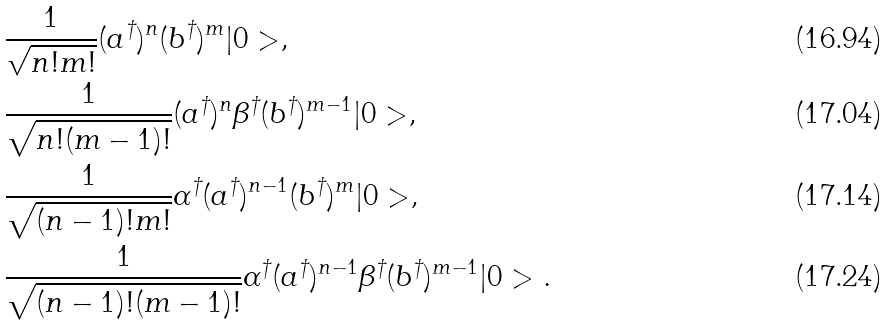Convert formula to latex. <formula><loc_0><loc_0><loc_500><loc_500>& \frac { 1 } { \sqrt { n ! m ! } } ( a ^ { \dagger } ) ^ { n } ( b ^ { \dagger } ) ^ { m } | 0 > , \\ & \frac { 1 } { \sqrt { n ! ( m - 1 ) ! } } ( a ^ { \dagger } ) ^ { n } \beta ^ { \dagger } ( b ^ { \dagger } ) ^ { m - 1 } | 0 > , \\ & \frac { 1 } { \sqrt { ( n - 1 ) ! m ! } } \alpha ^ { \dagger } ( a ^ { \dagger } ) ^ { n - 1 } ( b ^ { \dagger } ) ^ { m } | 0 > , \\ & \frac { 1 } { \sqrt { ( n - 1 ) ! ( m - 1 ) ! } } \alpha ^ { \dagger } ( a ^ { \dagger } ) ^ { n - 1 } \beta ^ { \dagger } ( b ^ { \dagger } ) ^ { m - 1 } | 0 > .</formula> 